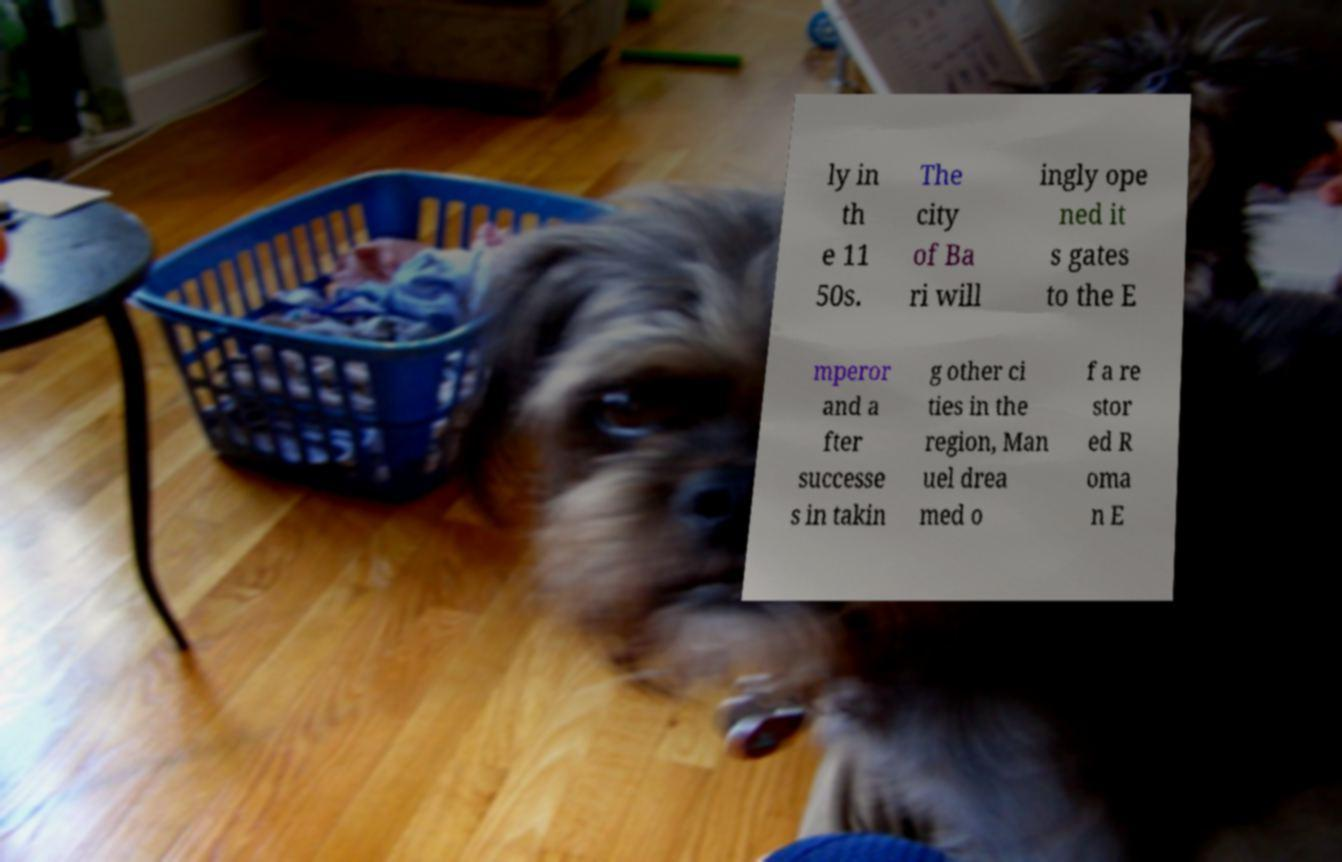Could you assist in decoding the text presented in this image and type it out clearly? ly in th e 11 50s. The city of Ba ri will ingly ope ned it s gates to the E mperor and a fter successe s in takin g other ci ties in the region, Man uel drea med o f a re stor ed R oma n E 